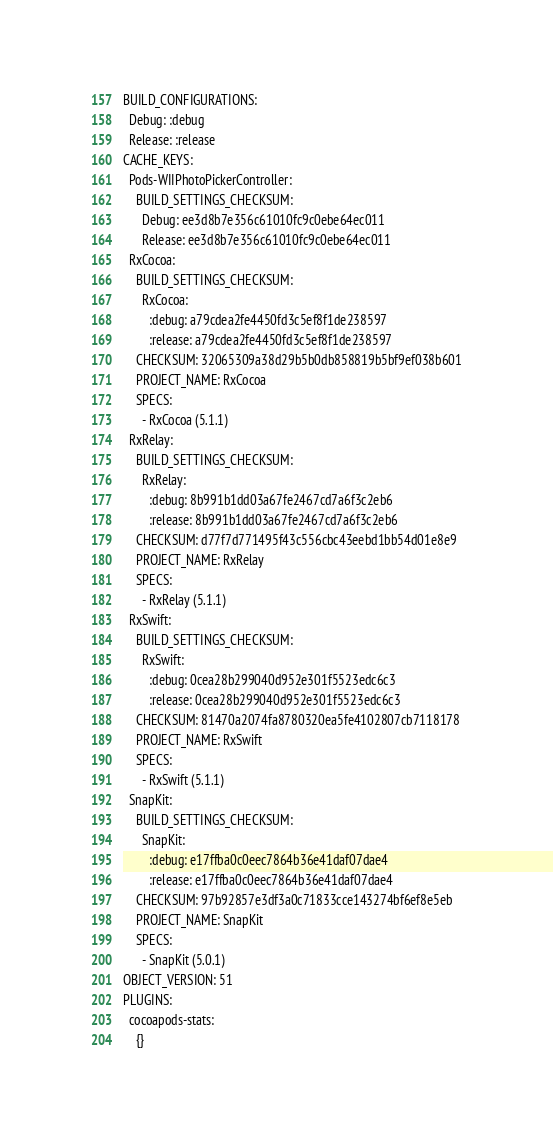Convert code to text. <code><loc_0><loc_0><loc_500><loc_500><_YAML_>BUILD_CONFIGURATIONS:
  Debug: :debug
  Release: :release
CACHE_KEYS:
  Pods-WIIPhotoPickerController:
    BUILD_SETTINGS_CHECKSUM:
      Debug: ee3d8b7e356c61010fc9c0ebe64ec011
      Release: ee3d8b7e356c61010fc9c0ebe64ec011
  RxCocoa:
    BUILD_SETTINGS_CHECKSUM:
      RxCocoa:
        :debug: a79cdea2fe4450fd3c5ef8f1de238597
        :release: a79cdea2fe4450fd3c5ef8f1de238597
    CHECKSUM: 32065309a38d29b5b0db858819b5bf9ef038b601
    PROJECT_NAME: RxCocoa
    SPECS:
      - RxCocoa (5.1.1)
  RxRelay:
    BUILD_SETTINGS_CHECKSUM:
      RxRelay:
        :debug: 8b991b1dd03a67fe2467cd7a6f3c2eb6
        :release: 8b991b1dd03a67fe2467cd7a6f3c2eb6
    CHECKSUM: d77f7d771495f43c556cbc43eebd1bb54d01e8e9
    PROJECT_NAME: RxRelay
    SPECS:
      - RxRelay (5.1.1)
  RxSwift:
    BUILD_SETTINGS_CHECKSUM:
      RxSwift:
        :debug: 0cea28b299040d952e301f5523edc6c3
        :release: 0cea28b299040d952e301f5523edc6c3
    CHECKSUM: 81470a2074fa8780320ea5fe4102807cb7118178
    PROJECT_NAME: RxSwift
    SPECS:
      - RxSwift (5.1.1)
  SnapKit:
    BUILD_SETTINGS_CHECKSUM:
      SnapKit:
        :debug: e17ffba0c0eec7864b36e41daf07dae4
        :release: e17ffba0c0eec7864b36e41daf07dae4
    CHECKSUM: 97b92857e3df3a0c71833cce143274bf6ef8e5eb
    PROJECT_NAME: SnapKit
    SPECS:
      - SnapKit (5.0.1)
OBJECT_VERSION: 51
PLUGINS:
  cocoapods-stats:
    {}
</code> 